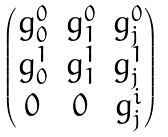Convert formula to latex. <formula><loc_0><loc_0><loc_500><loc_500>\begin{pmatrix} g ^ { 0 } _ { 0 } & g ^ { 0 } _ { 1 } & g ^ { 0 } _ { j } \\ g ^ { 1 } _ { 0 } & g ^ { 1 } _ { 1 } & g ^ { 1 } _ { j } \\ 0 & 0 & g ^ { i } _ { j } \end{pmatrix}</formula> 